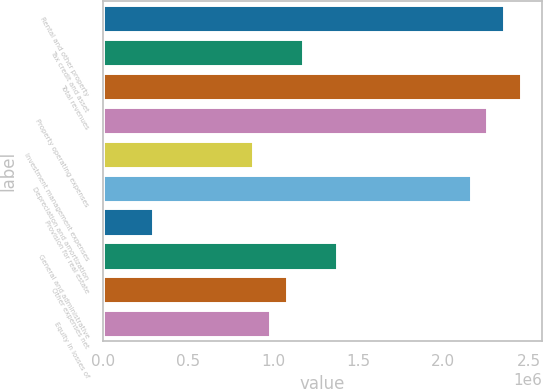<chart> <loc_0><loc_0><loc_500><loc_500><bar_chart><fcel>Rental and other property<fcel>Tax credit and asset<fcel>Total revenues<fcel>Property operating expenses<fcel>Investment management expenses<fcel>Depreciation and amortization<fcel>Provision for real estate<fcel>General and administrative<fcel>Other expenses net<fcel>Equity in losses of<nl><fcel>2.3566e+06<fcel>1.1783e+06<fcel>2.4548e+06<fcel>2.25841e+06<fcel>883727<fcel>2.16022e+06<fcel>294576<fcel>1.37469e+06<fcel>1.08011e+06<fcel>981919<nl></chart> 